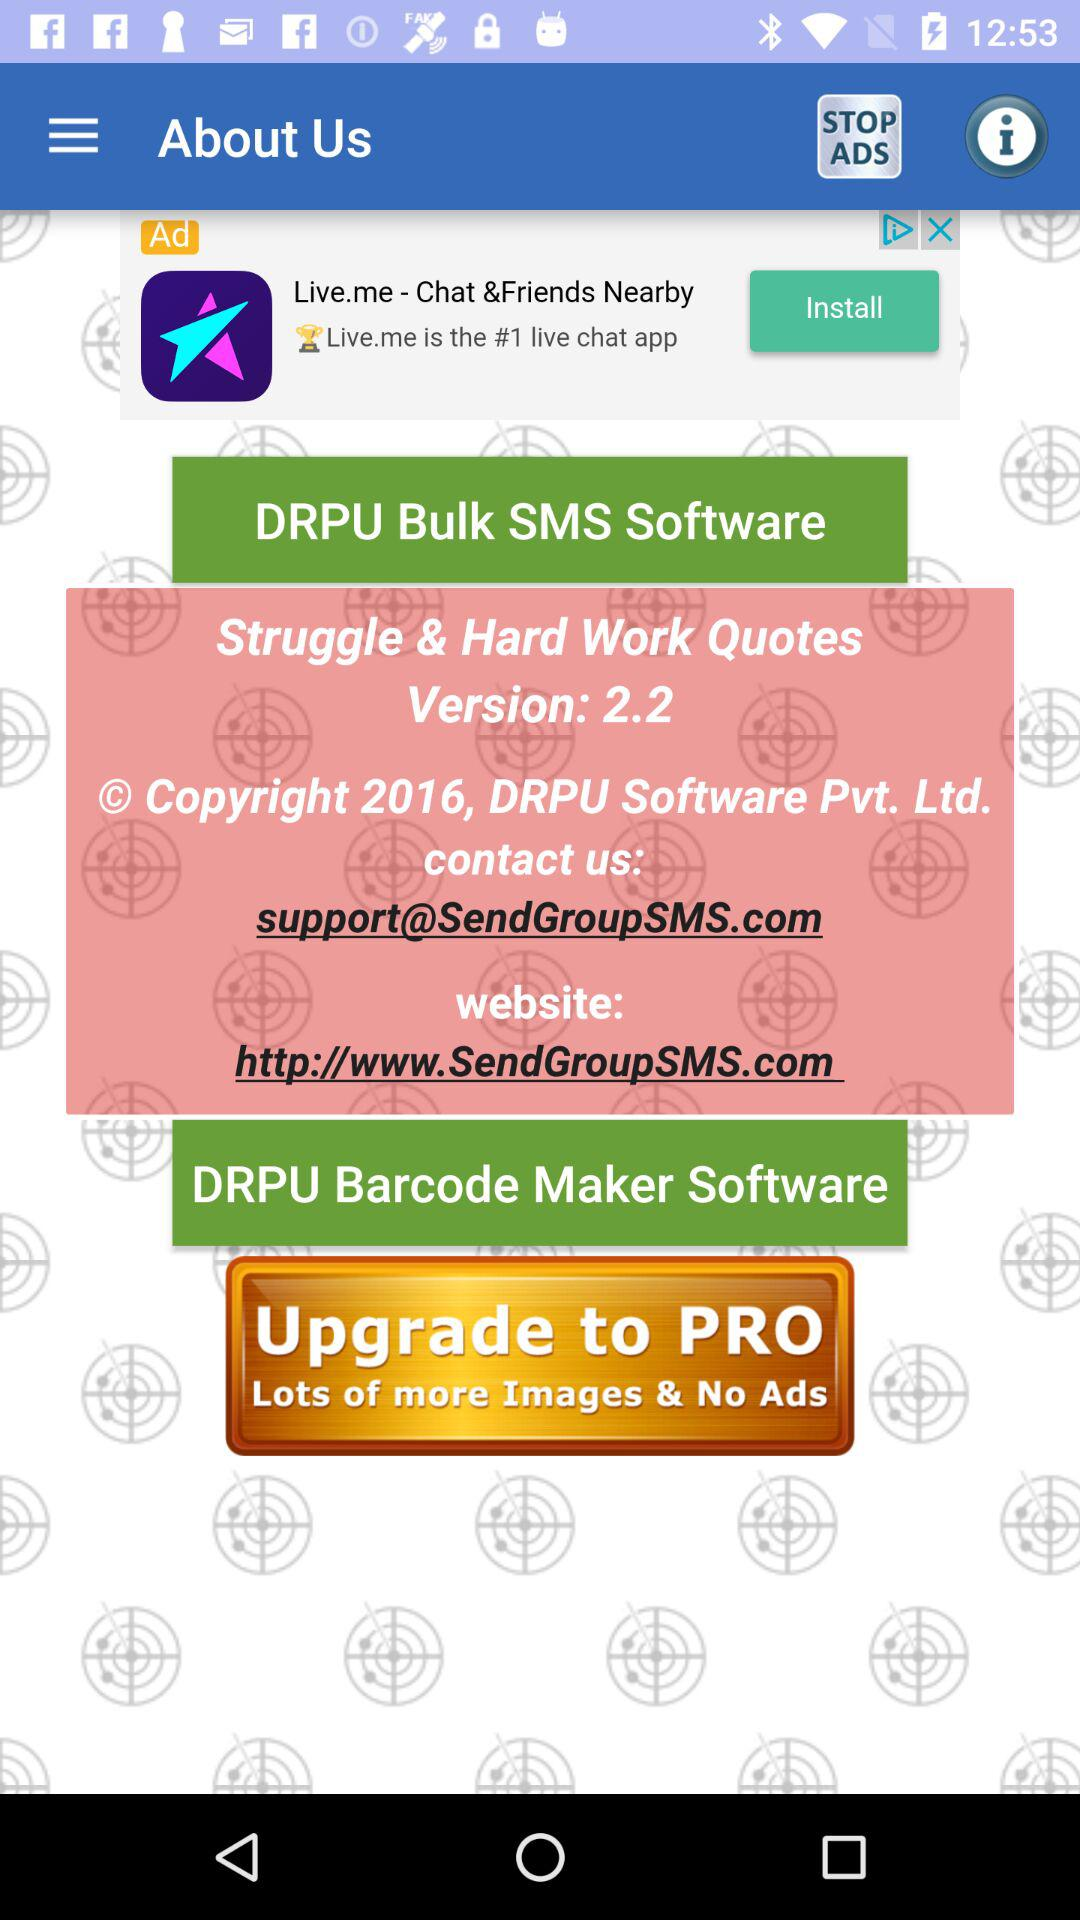What is the official website of "DRPU Barcode Maker Software"? The official website is http://www.SendGroupSMS.com. 